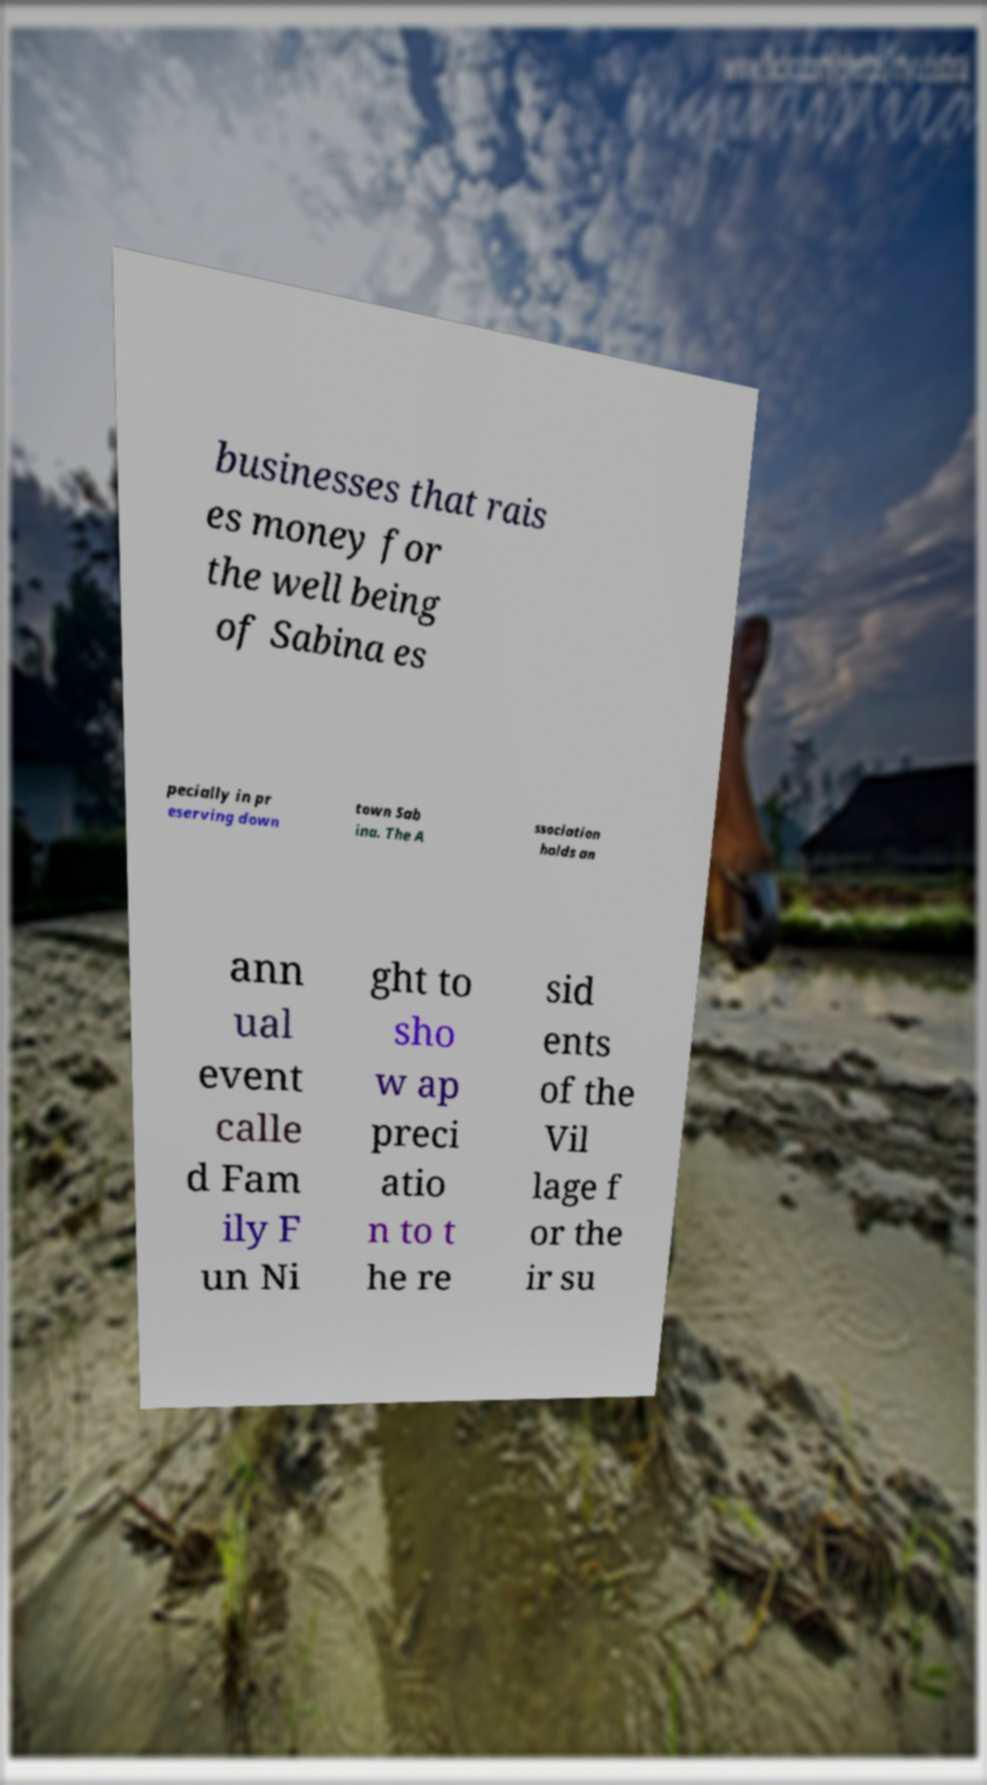For documentation purposes, I need the text within this image transcribed. Could you provide that? businesses that rais es money for the well being of Sabina es pecially in pr eserving down town Sab ina. The A ssociation holds an ann ual event calle d Fam ily F un Ni ght to sho w ap preci atio n to t he re sid ents of the Vil lage f or the ir su 